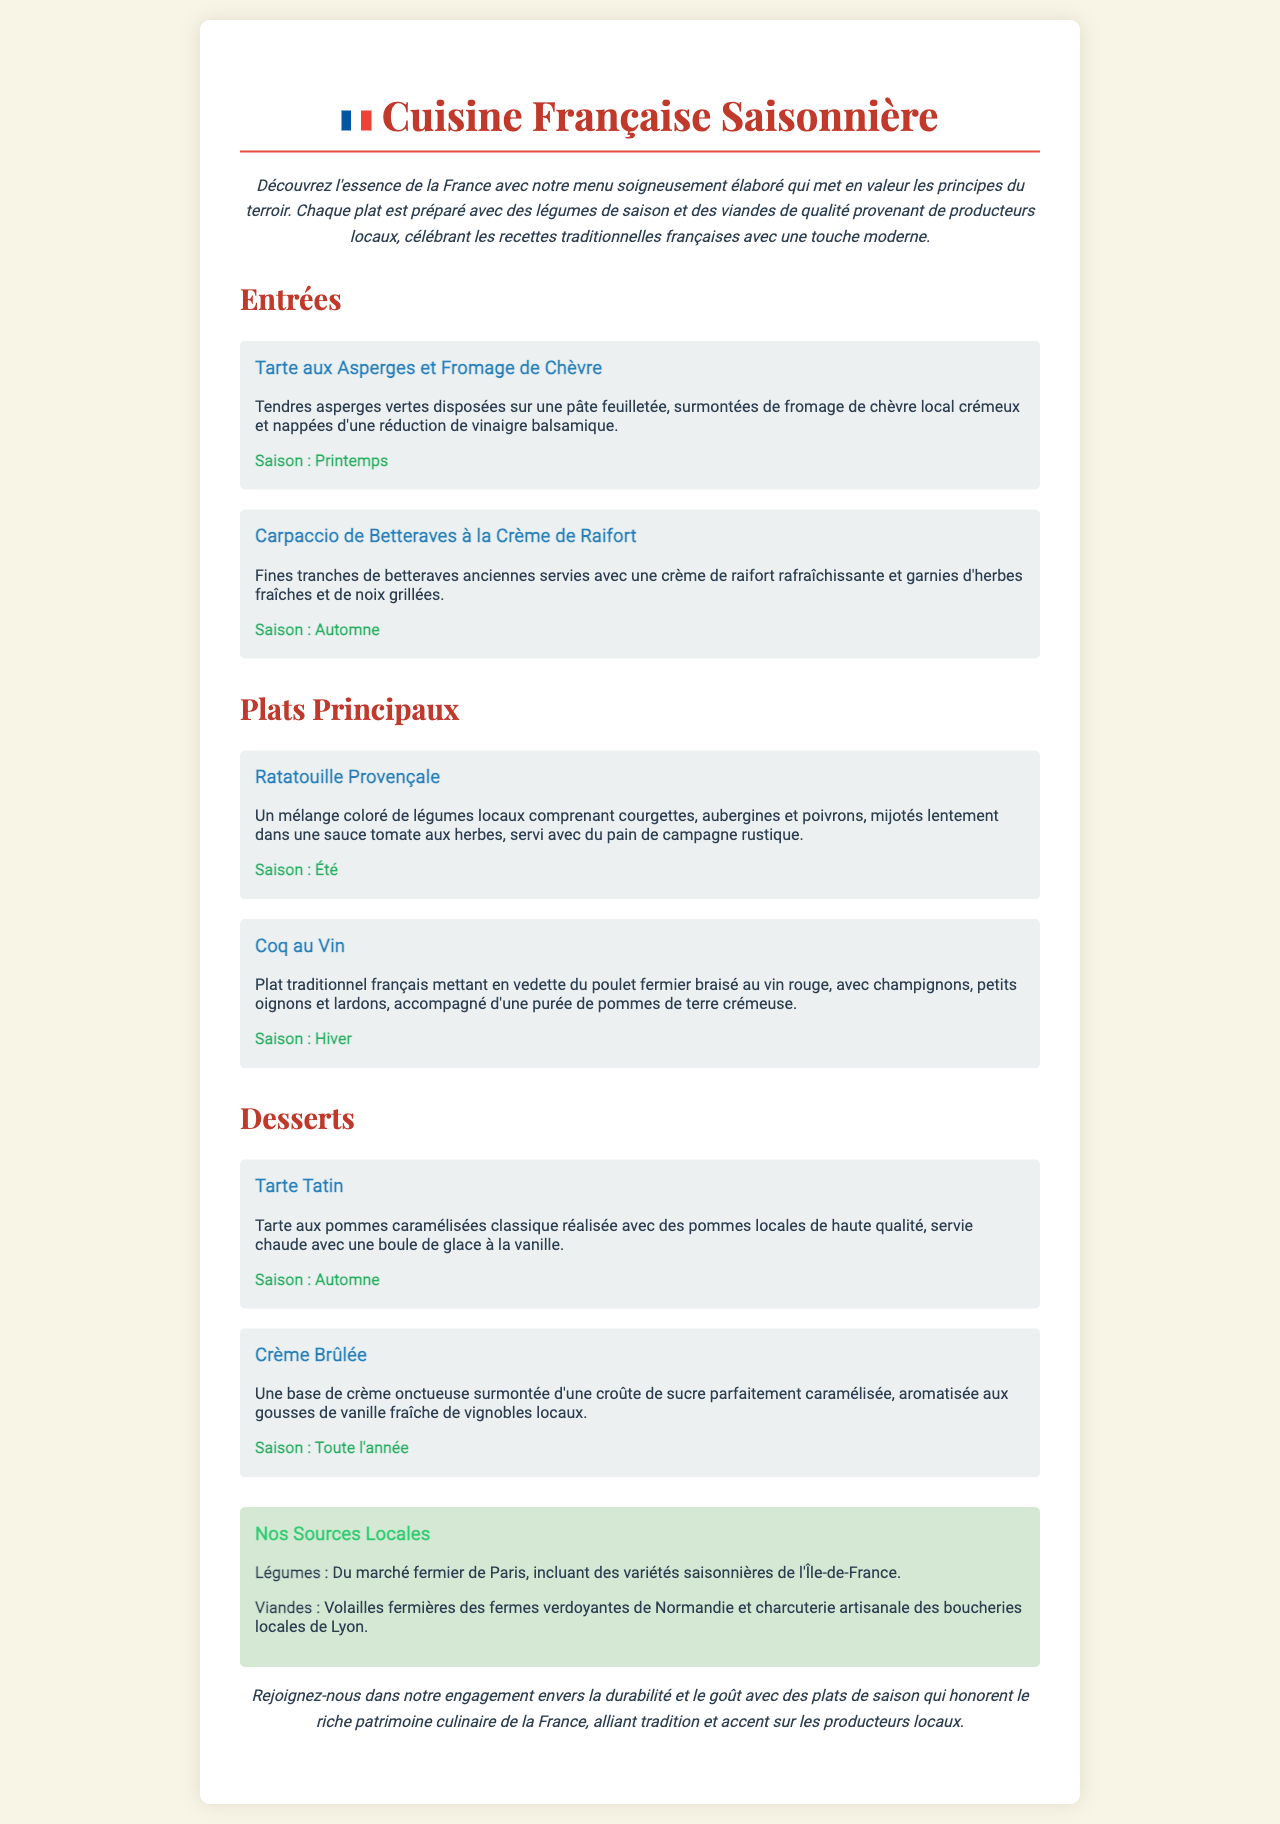What is the title of the menu? The title is located at the top of the document, indicating the theme of the menu.
Answer: Cuisine Française Saisonnière What are the two main types of dishes listed in the menu? The menu is organized into sections that categorize the dishes.
Answer: Entrées and Plats Principaux Which dish features asparagus? The specific dish is highlighted as an entrée, showcasing the use of seasonal vegetables.
Answer: Tarte aux Asperges et Fromage de Chèvre What season is associated with the Coq au Vin? Each dish includes a seasonal tag indicating the time of year it is best enjoyed.
Answer: Hiver Where do the vegetables come from? The document specifies the source of the ingredients, emphasizing local sourcing.
Answer: Du marché fermier de Paris What is a key feature of the Crème Brûlée? The dessert description highlights an essential attribute that is notable for this dish.
Answer: Une croûte de sucre parfaitement caramélisée How many desserts are listed on the menu? The desserts section includes a list of specific items presented in a clear format.
Answer: Deux What is highlighted as an aspect of the restaurant's commitment? The concluding remarks emphasize a particular principle or practice of the restaurant.
Answer: Durabilité Which dish is served with homemade ice cream? This specific dessert is identified in the menu for its pairing with another item.
Answer: Tarte Tatin 